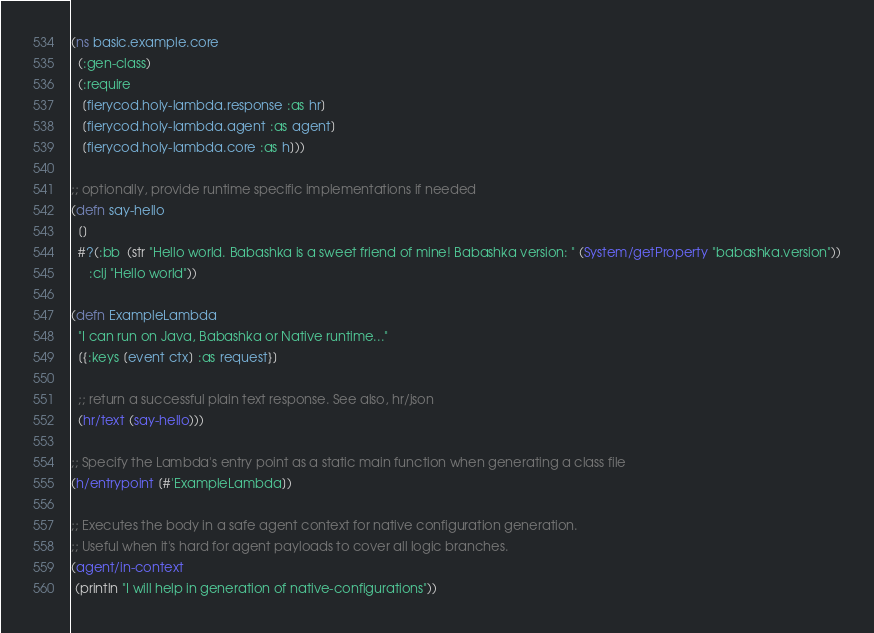<code> <loc_0><loc_0><loc_500><loc_500><_Clojure_>(ns basic.example.core
  (:gen-class)
  (:require
   [fierycod.holy-lambda.response :as hr]
   [fierycod.holy-lambda.agent :as agent]
   [fierycod.holy-lambda.core :as h]))

;; optionally, provide runtime specific implementations if needed
(defn say-hello
  []
  #?(:bb  (str "Hello world. Babashka is a sweet friend of mine! Babashka version: " (System/getProperty "babashka.version"))
     :clj "Hello world"))

(defn ExampleLambda
  "I can run on Java, Babashka or Native runtime..."
  [{:keys [event ctx] :as request}]

  ;; return a successful plain text response. See also, hr/json
  (hr/text (say-hello)))

;; Specify the Lambda's entry point as a static main function when generating a class file
(h/entrypoint [#'ExampleLambda])

;; Executes the body in a safe agent context for native configuration generation.
;; Useful when it's hard for agent payloads to cover all logic branches.
(agent/in-context
 (println "I will help in generation of native-configurations"))
</code> 